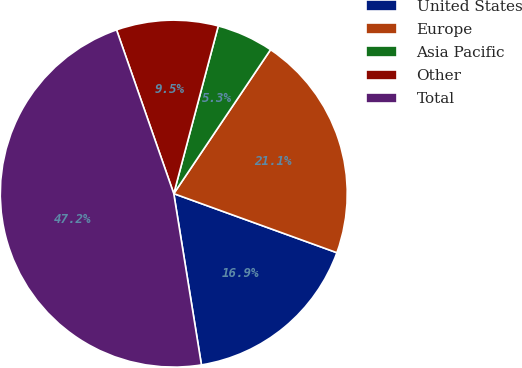Convert chart to OTSL. <chart><loc_0><loc_0><loc_500><loc_500><pie_chart><fcel>United States<fcel>Europe<fcel>Asia Pacific<fcel>Other<fcel>Total<nl><fcel>16.92%<fcel>21.11%<fcel>5.29%<fcel>9.48%<fcel>47.2%<nl></chart> 